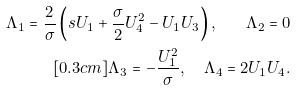Convert formula to latex. <formula><loc_0><loc_0><loc_500><loc_500>\Lambda _ { 1 } = \frac { 2 } { \sigma } \left ( s U _ { 1 } + \frac { \sigma } { 2 } U _ { 4 } ^ { 2 } - U _ { 1 } U _ { 3 } \right ) , \quad \Lambda _ { 2 } = 0 \\ [ 0 . 3 c m ] \Lambda _ { 3 } = - \frac { U _ { 1 } ^ { 2 } } { \sigma } , \quad \Lambda _ { 4 } = 2 U _ { 1 } U _ { 4 } .</formula> 